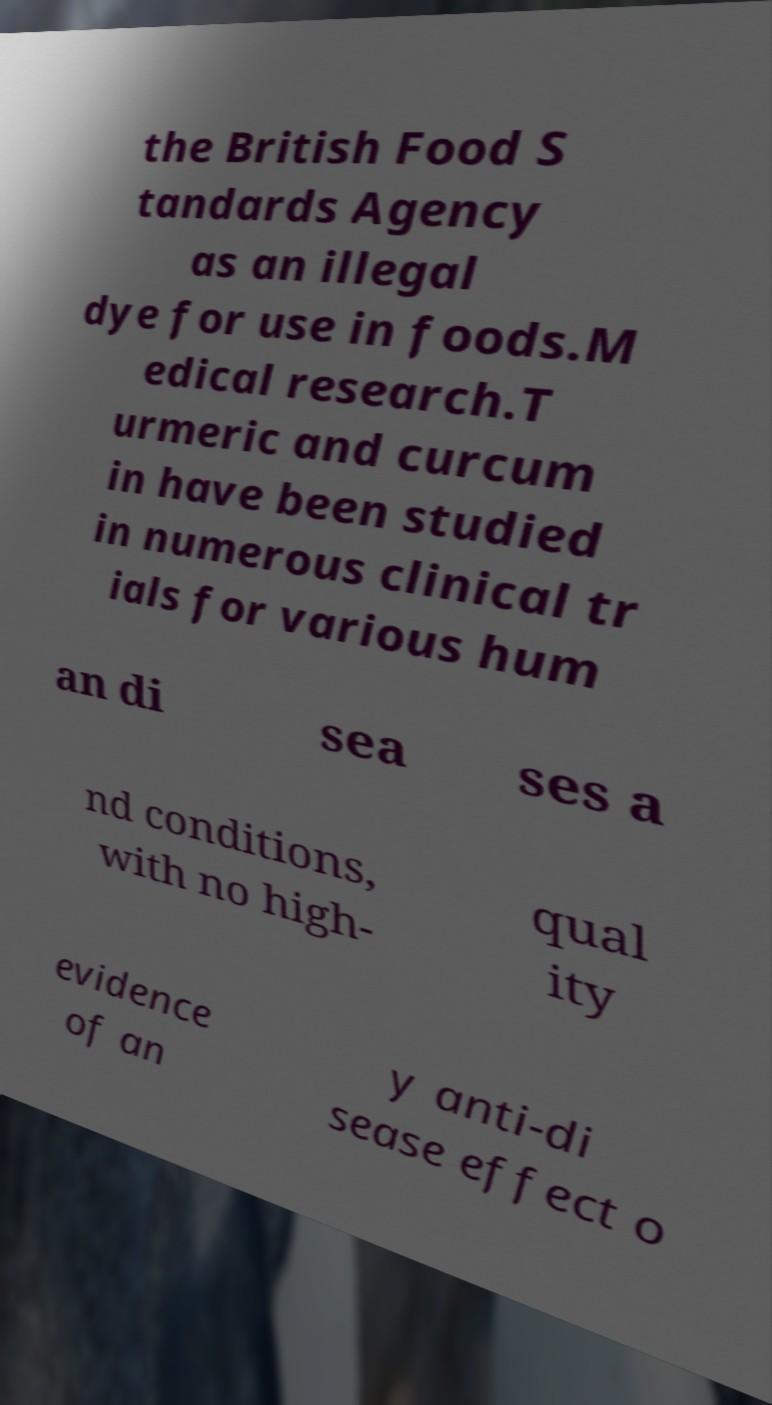For documentation purposes, I need the text within this image transcribed. Could you provide that? the British Food S tandards Agency as an illegal dye for use in foods.M edical research.T urmeric and curcum in have been studied in numerous clinical tr ials for various hum an di sea ses a nd conditions, with no high- qual ity evidence of an y anti-di sease effect o 